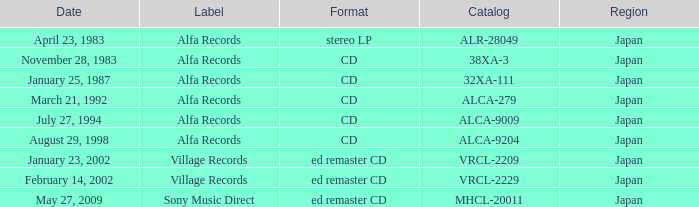Which catalog is in cd format? 38XA-3, 32XA-111, ALCA-279, ALCA-9009, ALCA-9204. 